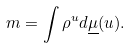<formula> <loc_0><loc_0><loc_500><loc_500>m = \int \rho ^ { u } d \underline { \mu } ( u ) .</formula> 